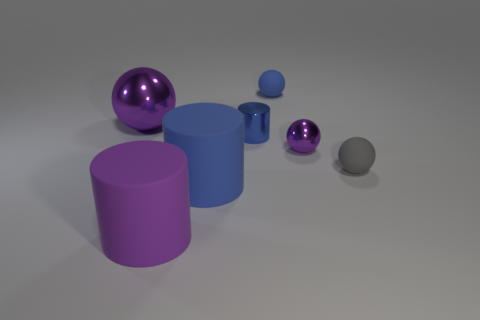Add 1 blue rubber blocks. How many objects exist? 8 Subtract all cylinders. How many objects are left? 4 Add 3 small matte things. How many small matte things are left? 5 Add 6 large purple cylinders. How many large purple cylinders exist? 7 Subtract 0 cyan cylinders. How many objects are left? 7 Subtract all rubber cylinders. Subtract all large purple objects. How many objects are left? 3 